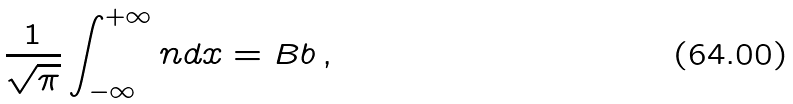Convert formula to latex. <formula><loc_0><loc_0><loc_500><loc_500>\frac { 1 } { \sqrt { \pi } } \int _ { - \infty } ^ { + \infty } n d x = B b \, ,</formula> 